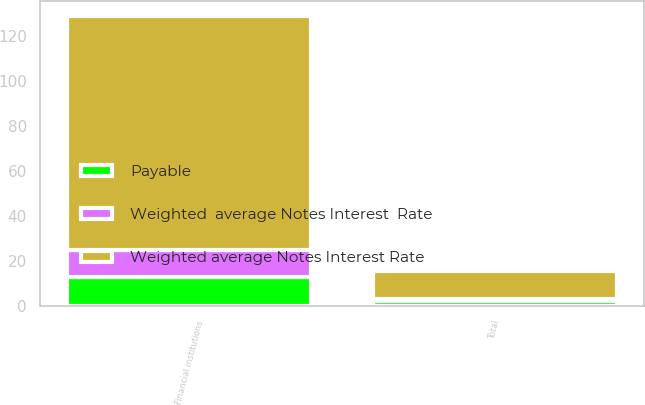Convert chart. <chart><loc_0><loc_0><loc_500><loc_500><stacked_bar_chart><ecel><fcel>Financial institutions<fcel>Total<nl><fcel>Weighted average Notes Interest Rate<fcel>104.1<fcel>12.1<nl><fcel>Weighted  average Notes Interest  Rate<fcel>12.1<fcel>1.3<nl><fcel>Payable<fcel>13<fcel>2<nl></chart> 